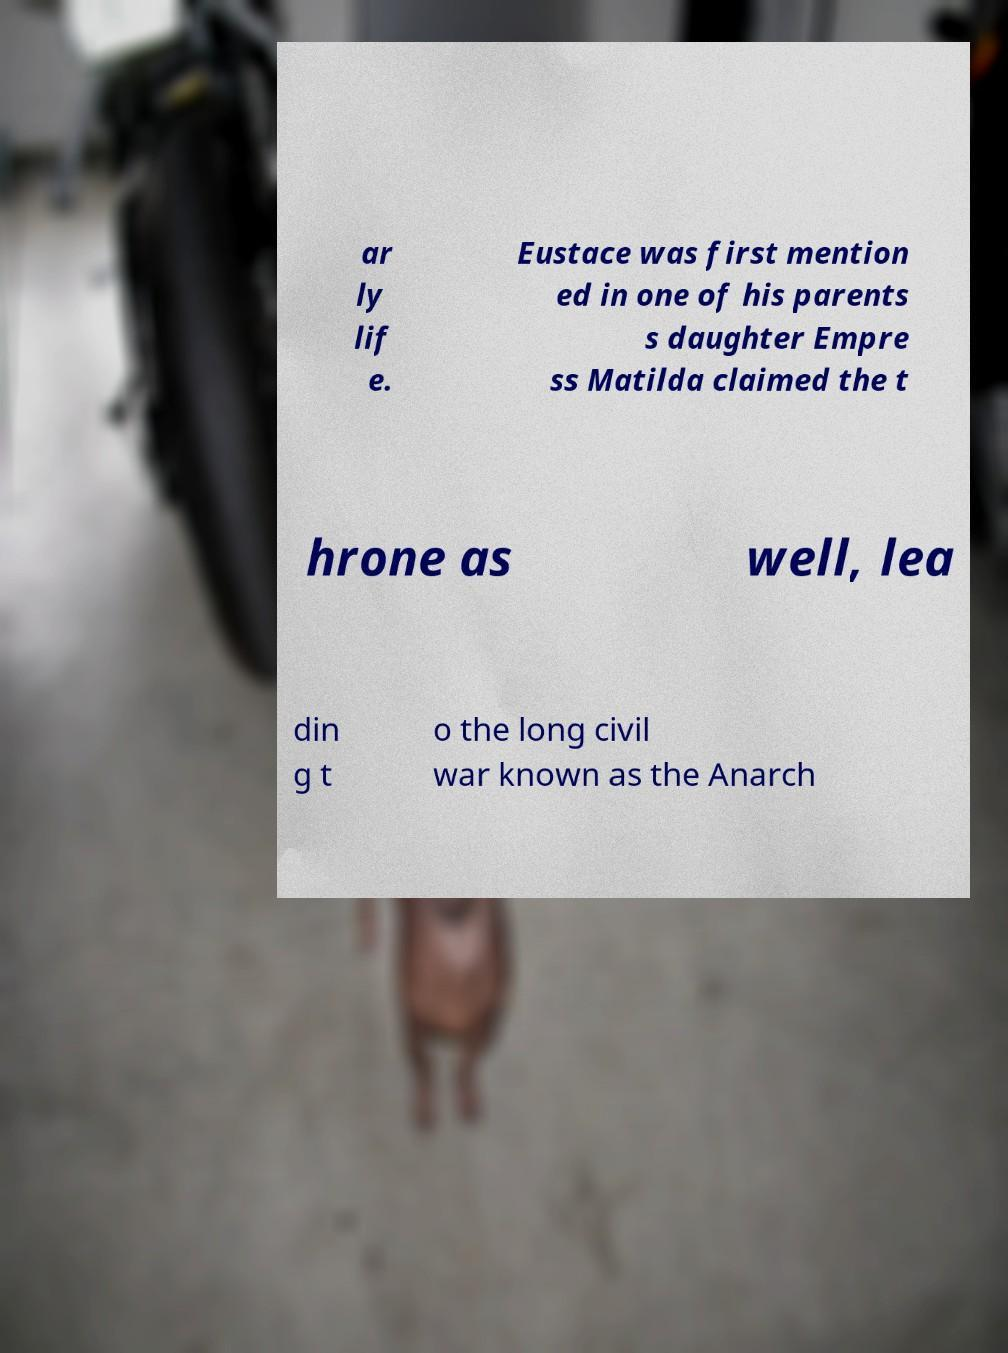Could you extract and type out the text from this image? ar ly lif e. Eustace was first mention ed in one of his parents s daughter Empre ss Matilda claimed the t hrone as well, lea din g t o the long civil war known as the Anarch 